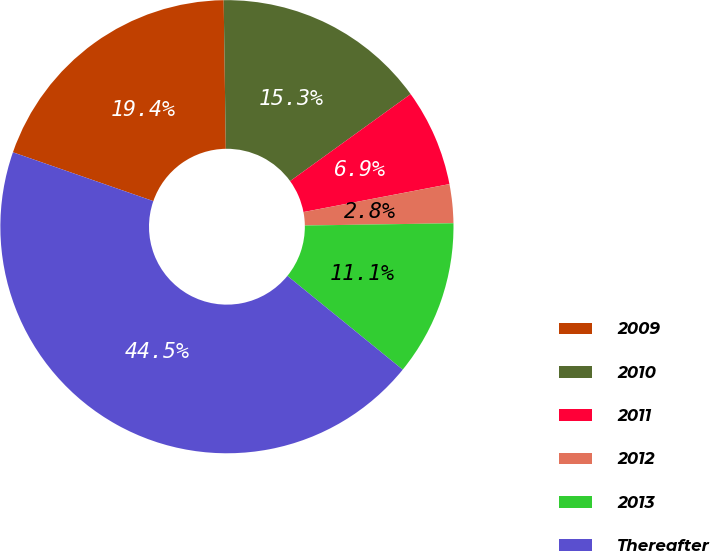Convert chart. <chart><loc_0><loc_0><loc_500><loc_500><pie_chart><fcel>2009<fcel>2010<fcel>2011<fcel>2012<fcel>2013<fcel>Thereafter<nl><fcel>19.45%<fcel>15.28%<fcel>6.94%<fcel>2.77%<fcel>11.11%<fcel>44.47%<nl></chart> 